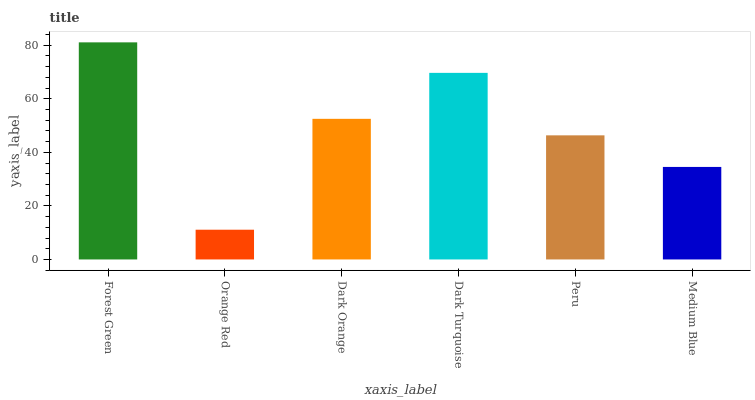Is Dark Orange the minimum?
Answer yes or no. No. Is Dark Orange the maximum?
Answer yes or no. No. Is Dark Orange greater than Orange Red?
Answer yes or no. Yes. Is Orange Red less than Dark Orange?
Answer yes or no. Yes. Is Orange Red greater than Dark Orange?
Answer yes or no. No. Is Dark Orange less than Orange Red?
Answer yes or no. No. Is Dark Orange the high median?
Answer yes or no. Yes. Is Peru the low median?
Answer yes or no. Yes. Is Dark Turquoise the high median?
Answer yes or no. No. Is Medium Blue the low median?
Answer yes or no. No. 